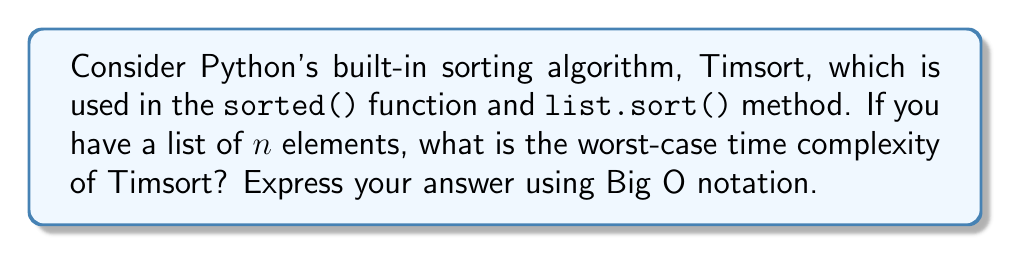Give your solution to this math problem. To analyze the time complexity of Timsort, we need to understand its core principles:

1. Timsort is a hybrid sorting algorithm that combines elements of Merge sort and Insertion sort.

2. It divides the input list into small runs (typically 32 or 64 elements), sorts these runs using Insertion sort, and then merges the sorted runs using a variation of Merge sort.

3. The algorithm adapts to the input data, performing well on both random and partially sorted data.

Let's break down the complexity:

a) Dividing the list into runs: $O(n)$
   - This step involves a linear scan of the input.

b) Sorting each run with Insertion sort:
   - Worst case for each run: $O(k^2)$, where $k$ is the run size (constant)
   - Total runs: $n/k$
   - Total complexity for this step: $O(n/k * k^2) = O(nk)$
   - Since $k$ is constant, this simplifies to $O(n)$

c) Merging the sorted runs:
   - This step uses a variation of Merge sort
   - Worst-case complexity of Merge sort: $O(n \log n)$

The overall time complexity is the sum of these steps:

$$O(n) + O(n) + O(n \log n) = O(n \log n)$$

The dominant term is $O(n \log n)$, which represents the merging step.

It's worth noting that while the average-case complexity of Timsort is also $O(n \log n)$, it performs exceptionally well on partially sorted data, approaching $O(n)$ in the best case. However, the question asks for the worst-case scenario.
Answer: $O(n \log n)$ 